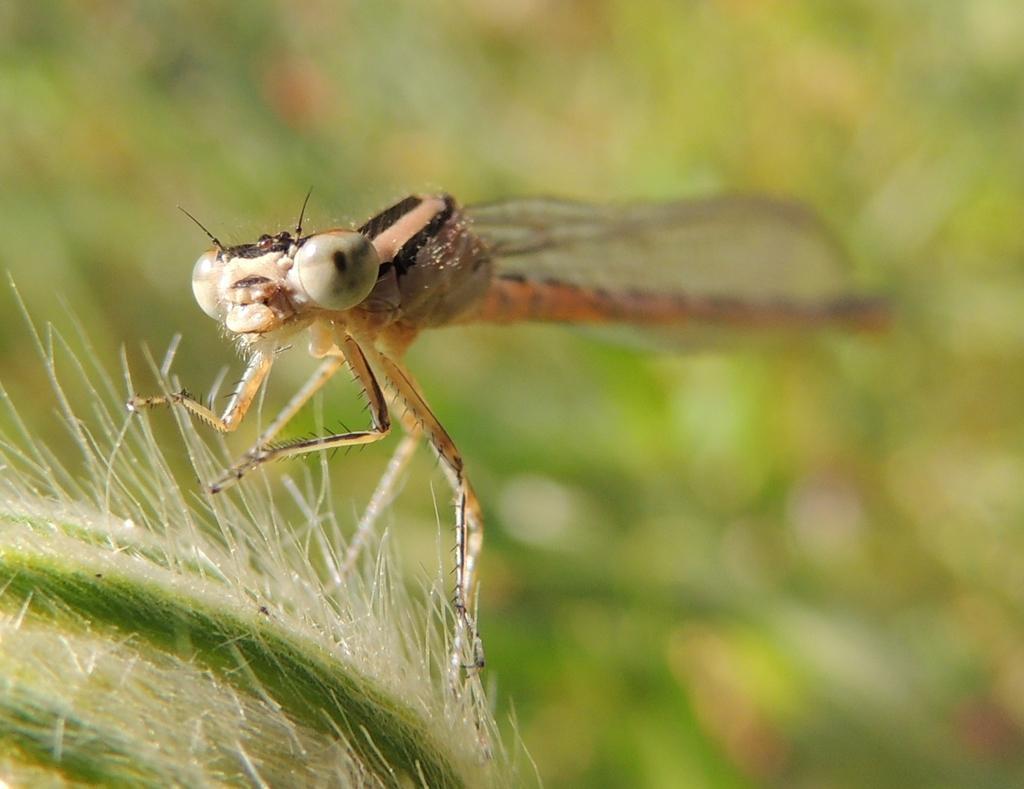In one or two sentences, can you explain what this image depicts? In this image we can see dragon fly on an object. In the background it is blur. 